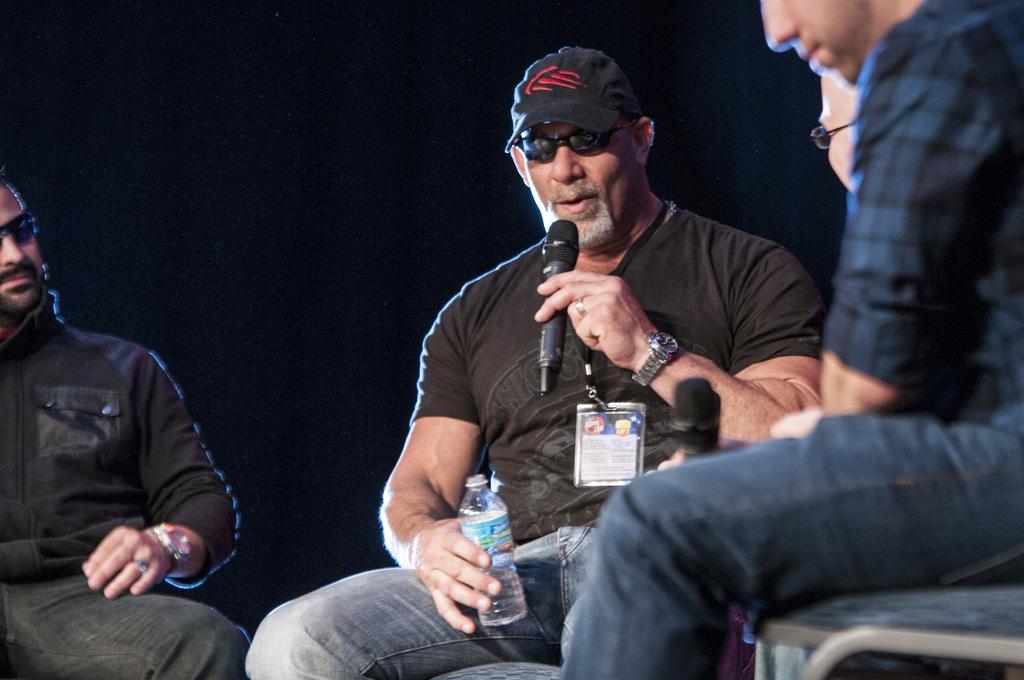Describe this image in one or two sentences. This is a picture of three people, two among them are wearing black color shirts and have watches on their wrist, shades and one of them is having a bottle in his right hand, a hat and holding a mike in his left hand and has a id card. 